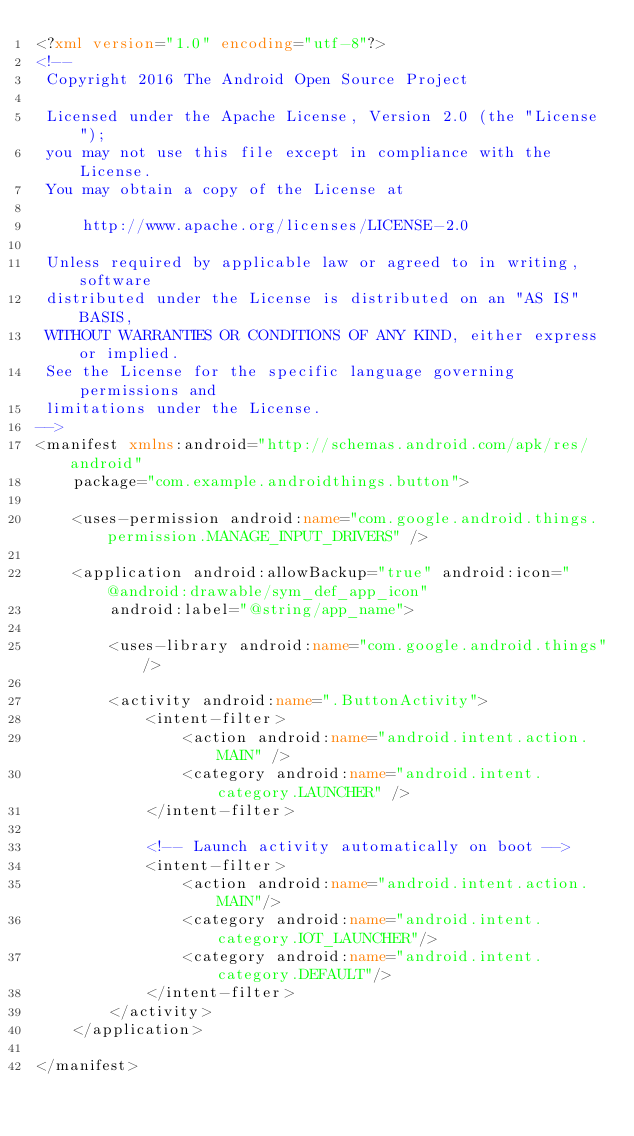<code> <loc_0><loc_0><loc_500><loc_500><_XML_><?xml version="1.0" encoding="utf-8"?>
<!--
 Copyright 2016 The Android Open Source Project

 Licensed under the Apache License, Version 2.0 (the "License");
 you may not use this file except in compliance with the License.
 You may obtain a copy of the License at

     http://www.apache.org/licenses/LICENSE-2.0

 Unless required by applicable law or agreed to in writing, software
 distributed under the License is distributed on an "AS IS" BASIS,
 WITHOUT WARRANTIES OR CONDITIONS OF ANY KIND, either express or implied.
 See the License for the specific language governing permissions and
 limitations under the License.
-->
<manifest xmlns:android="http://schemas.android.com/apk/res/android"
    package="com.example.androidthings.button">

    <uses-permission android:name="com.google.android.things.permission.MANAGE_INPUT_DRIVERS" />

    <application android:allowBackup="true" android:icon="@android:drawable/sym_def_app_icon"
        android:label="@string/app_name">

        <uses-library android:name="com.google.android.things"/>

        <activity android:name=".ButtonActivity">
            <intent-filter>
                <action android:name="android.intent.action.MAIN" />
                <category android:name="android.intent.category.LAUNCHER" />
            </intent-filter>

            <!-- Launch activity automatically on boot -->
            <intent-filter>
                <action android:name="android.intent.action.MAIN"/>
                <category android:name="android.intent.category.IOT_LAUNCHER"/>
                <category android:name="android.intent.category.DEFAULT"/>
            </intent-filter>
        </activity>
    </application>

</manifest>
</code> 